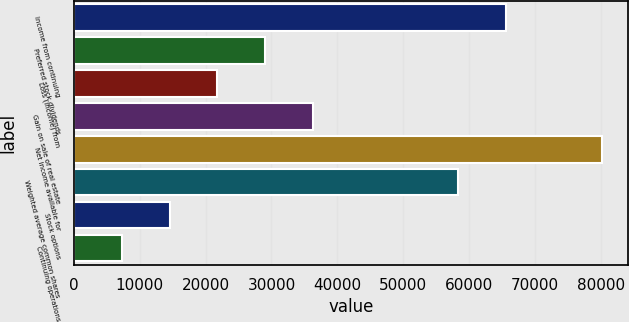Convert chart. <chart><loc_0><loc_0><loc_500><loc_500><bar_chart><fcel>Income from continuing<fcel>Preferred stock dividends<fcel>Loss (income) from<fcel>Gain on sale of real estate<fcel>Net income available for<fcel>Weighted average common shares<fcel>Stock options<fcel>Continuing operations<nl><fcel>65544.2<fcel>29072.5<fcel>21804.4<fcel>36340.6<fcel>80080.4<fcel>58276.1<fcel>14536.3<fcel>7268.21<nl></chart> 